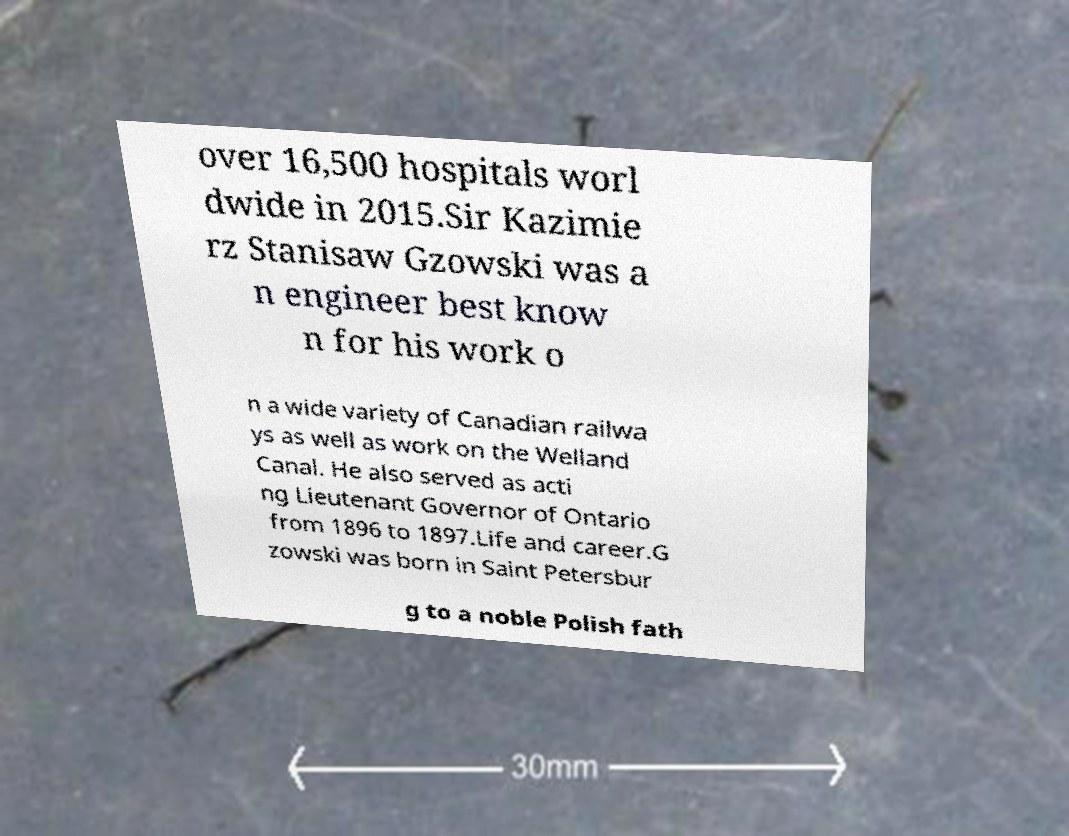I need the written content from this picture converted into text. Can you do that? over 16,500 hospitals worl dwide in 2015.Sir Kazimie rz Stanisaw Gzowski was a n engineer best know n for his work o n a wide variety of Canadian railwa ys as well as work on the Welland Canal. He also served as acti ng Lieutenant Governor of Ontario from 1896 to 1897.Life and career.G zowski was born in Saint Petersbur g to a noble Polish fath 